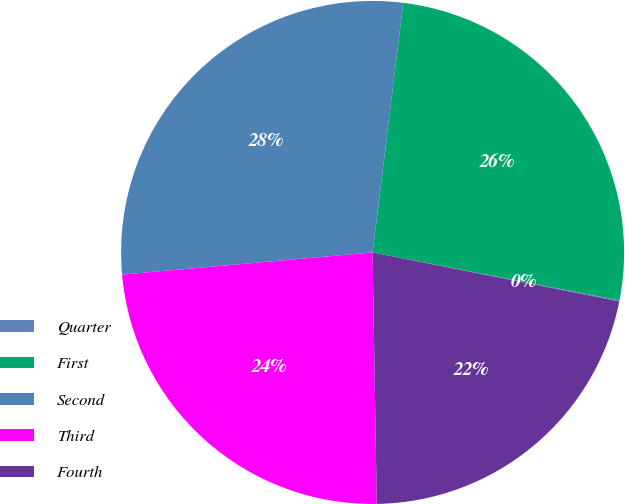<chart> <loc_0><loc_0><loc_500><loc_500><pie_chart><fcel>Quarter<fcel>First<fcel>Second<fcel>Third<fcel>Fourth<nl><fcel>0.06%<fcel>26.11%<fcel>28.35%<fcel>23.86%<fcel>21.62%<nl></chart> 